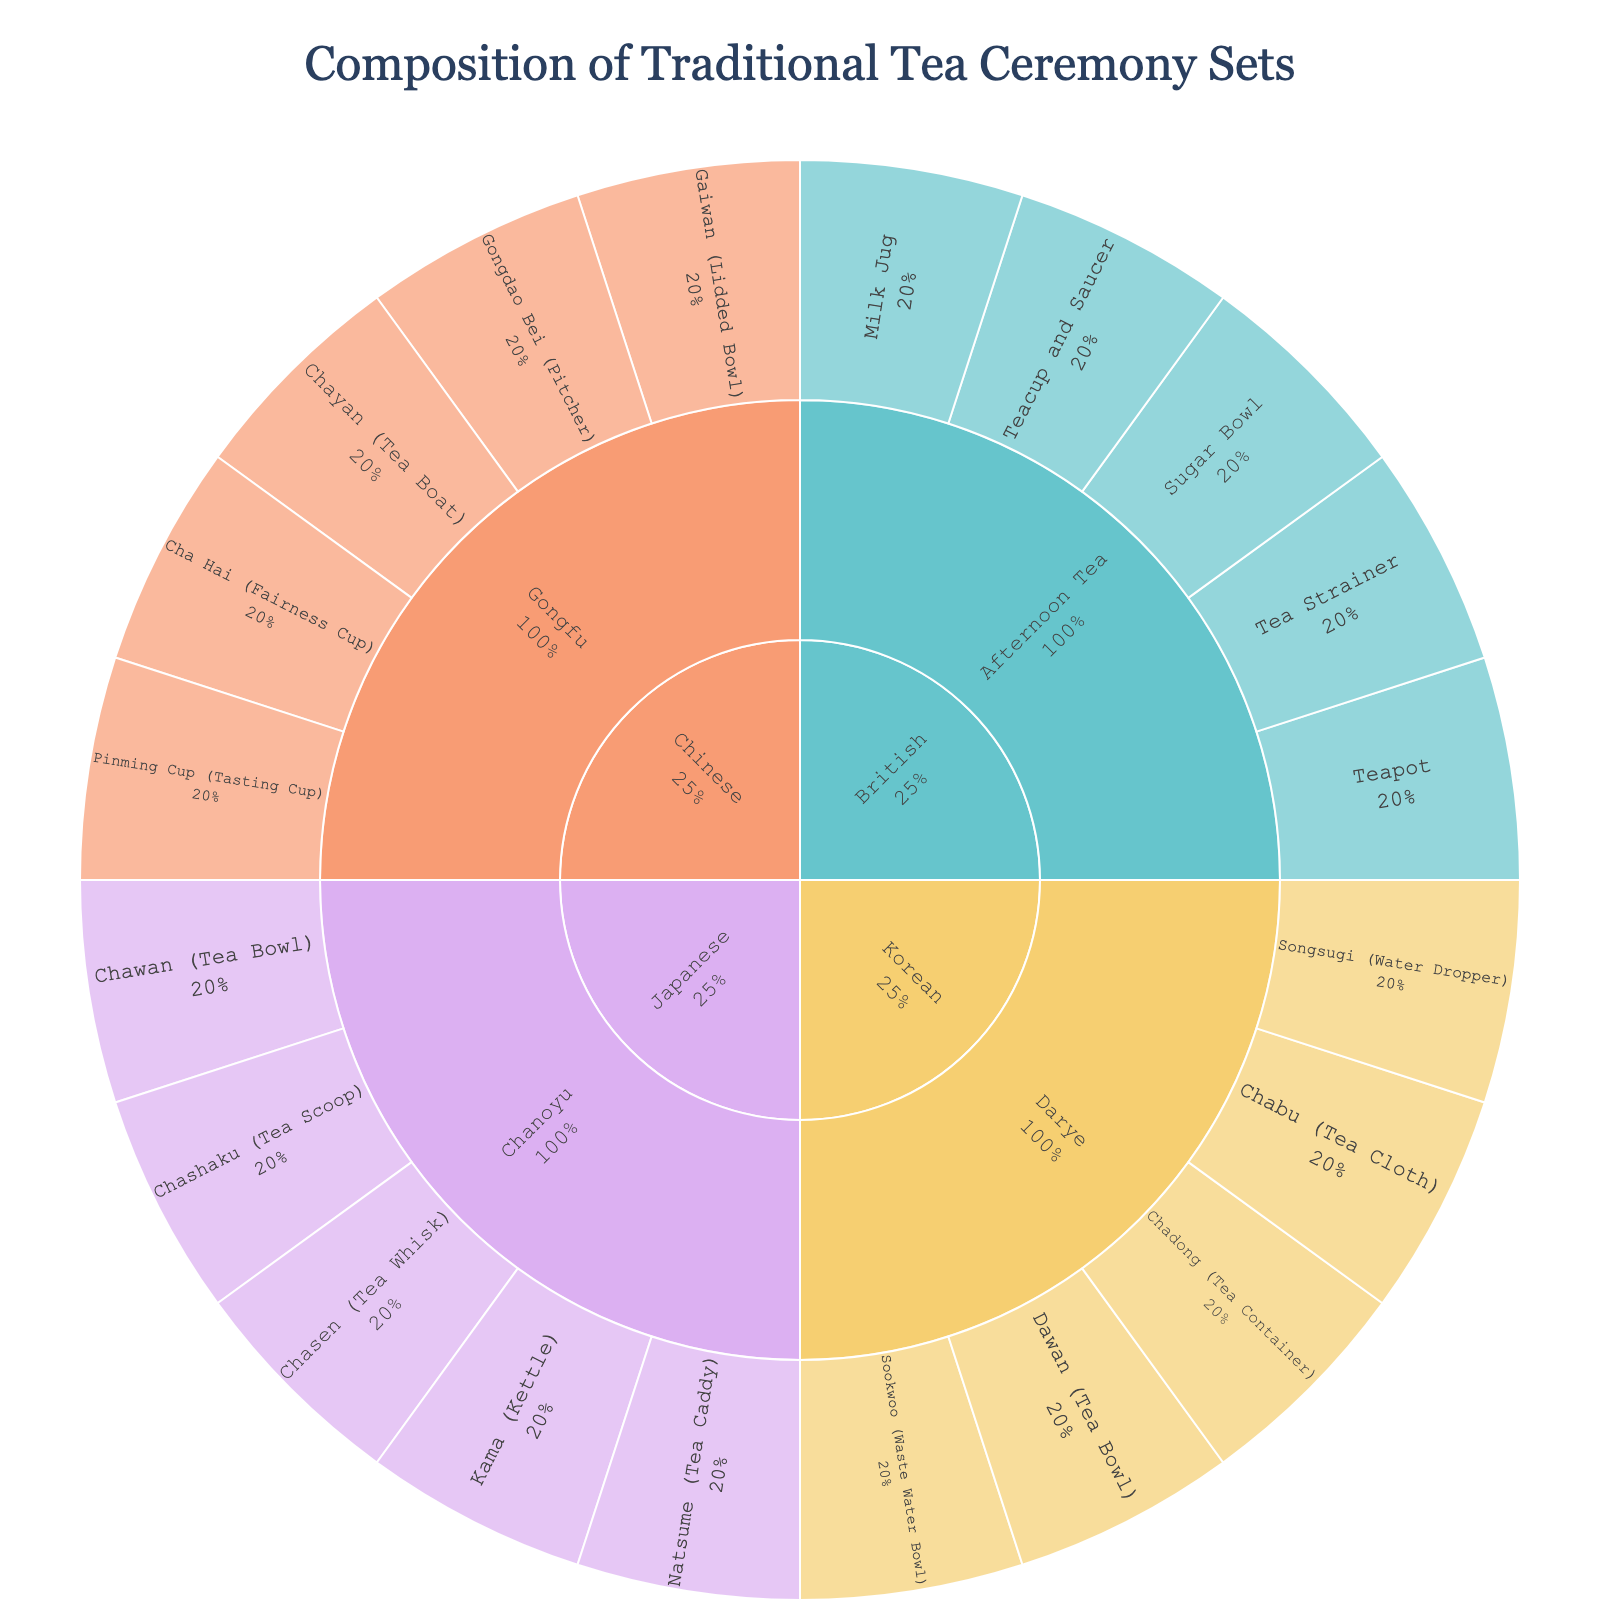what is the title of the figure? The title is usually displayed at the top of the plot. It summarizes the main focus of the data visualized.
Answer: Composition of Traditional Tea Ceremony Sets Which cultural origin has the largest number of components in the plot? You can determine this by identifying which cultural origin has the most segments when you add up all the components under each ritual.
Answer: Japanese How many Japanese Chanoyu components are there? Look at the segments branching from 'Japanese' and note the number of components listed under 'Chanoyu'.
Answer: 5 Compare the number of components in Chinese Gongfu and Korean Darye. Which one has more components? Count the segments under 'Chinese Gongfu' and 'Korean Darye' separately, then compare the totals.
Answer: Chinese Gongfu What percentage of the total components does the British Afternoon Tea represent? First, count the total number of components in the plot. Then, count the number of components under 'British Afternoon Tea'. Divide the latter by the former and multiply by 100 to get the percentage.
Answer: 5/20, so 25% Which ritual has the smallest number of unique components? Identify the rituals listed under each cultural origin and count the unique components for each. The one with the smallest count has the fewest unique components.
Answer: Korean Darye Is there a ritual where all components are exclusive to one cultural origin? If so, which one? Scroll through the segments linked to each ritual and confirm if all components exclusively belong to one cultural origin; there isn't an overlap with components from other origins.
Answer: Yes, Afternoon Tea (British) How many different types of tea bowls are there across all rituals? Tea bowls might be named differently in each culture. Count all the unique terms referring to tea bowls from each segment under rituals.
Answer: 3 Which origin has the most diverse range of components across its rituals? Check each cultural origin and count the range of different components listed under each. The one with the most different components has the highest diversity.
Answer: Chinese Do British rituals have any components in common with Japanese or Chinese rituals? Compare the components listed under 'British Afternoon Tea' with those under 'Japanese' and 'Chinese' origins to see if there are overlaps.
Answer: No 